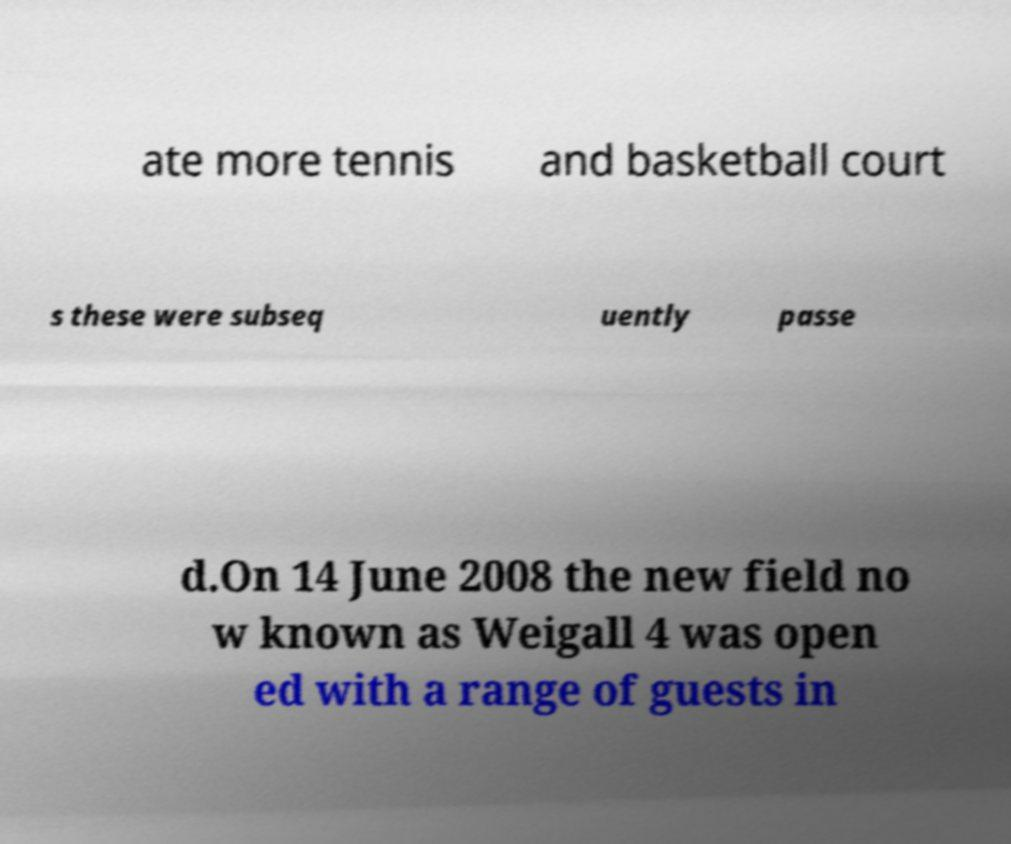Can you accurately transcribe the text from the provided image for me? ate more tennis and basketball court s these were subseq uently passe d.On 14 June 2008 the new field no w known as Weigall 4 was open ed with a range of guests in 